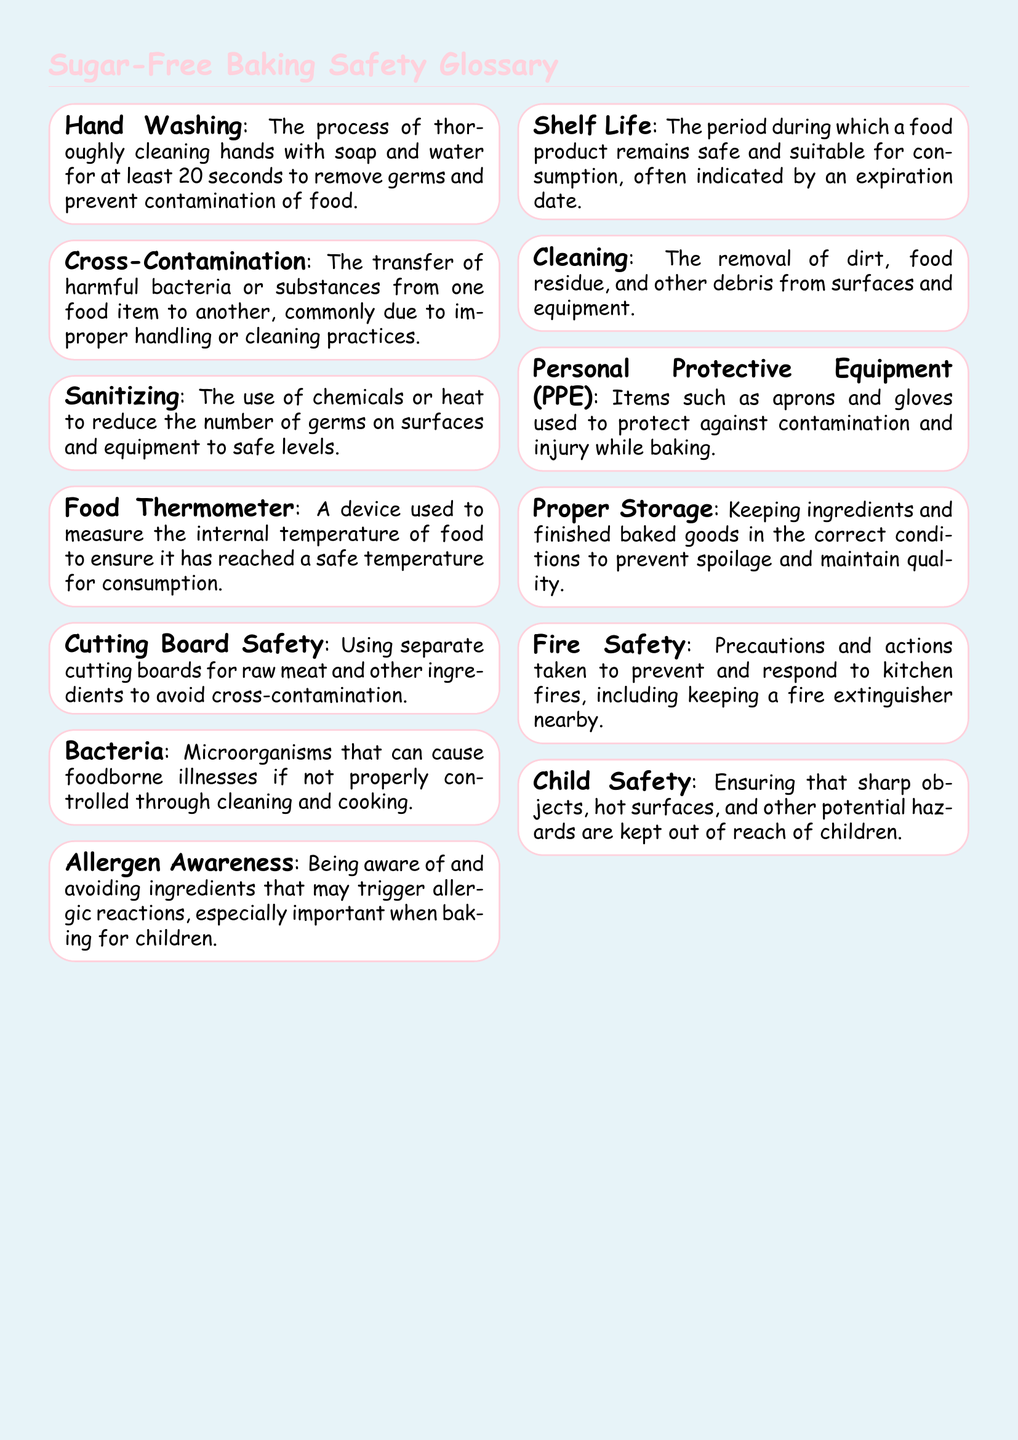What is the appropriate duration for hand washing? The document states that hands should be washed for at least 20 seconds to effectively remove germs.
Answer: 20 seconds What does cross-contamination refer to? Cross-contamination is described as the transfer of harmful bacteria or substances from one food item to another due to improper handling or cleaning practices.
Answer: Transfer of harmful bacteria or substances What is used to measure the internal temperature of food? The document specifies that a food thermometer is a device used for measuring the internal temperature to ensure safety.
Answer: Food Thermometer What is the term for awareness of ingredients that may trigger allergic reactions? The glossary refers to this as allergen awareness, which is important for baking for children.
Answer: Allergen Awareness What should be done to prevent spoilage of baked goods? The document mentions that proper storage is necessary to keep ingredients and finished baked goods in the right conditions.
Answer: Proper Storage What does PPE stand for in the context of baking? The glossary defines PPE as personal protective equipment, which includes items like aprons and gloves for safety.
Answer: Personal Protective Equipment Why is shelf life important in baking? Understanding shelf life is crucial for knowing how long a food product remains safe and suitable for consumption, indicated by an expiration date.
Answer: Period during which a food product remains safe What is an important safety precaution when using the oven? The glossary mentions fire safety measures that should be taken to prevent and respond to kitchen fires.
Answer: Fire Safety How can one ensure child safety while baking? The document emphasizes keeping sharp objects and hot surfaces out of reach of children as a method to ensure their safety.
Answer: Ensure sharp objects and hot surfaces are out of reach 